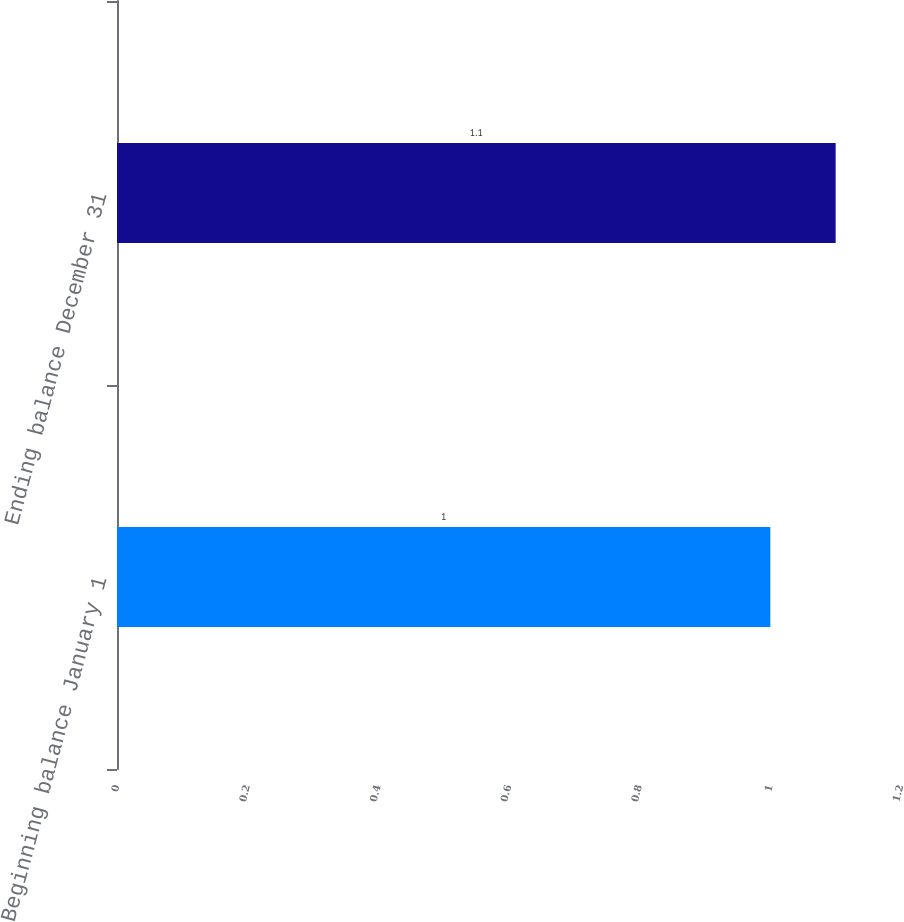<chart> <loc_0><loc_0><loc_500><loc_500><bar_chart><fcel>Beginning balance January 1<fcel>Ending balance December 31<nl><fcel>1<fcel>1.1<nl></chart> 